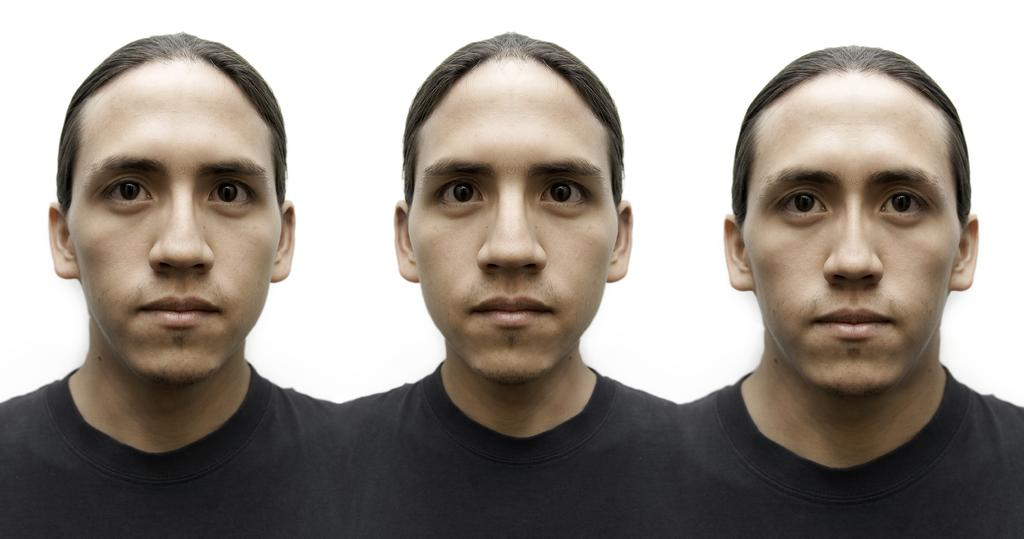What is the main subject of the image? There is a person in the image. What is the person wearing? The person is wearing a black color T-shirt. How many different expressions does the person have in the image? The person has three different expressions. What is the color of the background in the image? The background of the image is white. What type of hen can be seen in the image? There is no hen present in the image; it features a person with different expressions. What is the person selecting in the image? The provided facts do not mention any selection process or object being selected by the person in the image. 